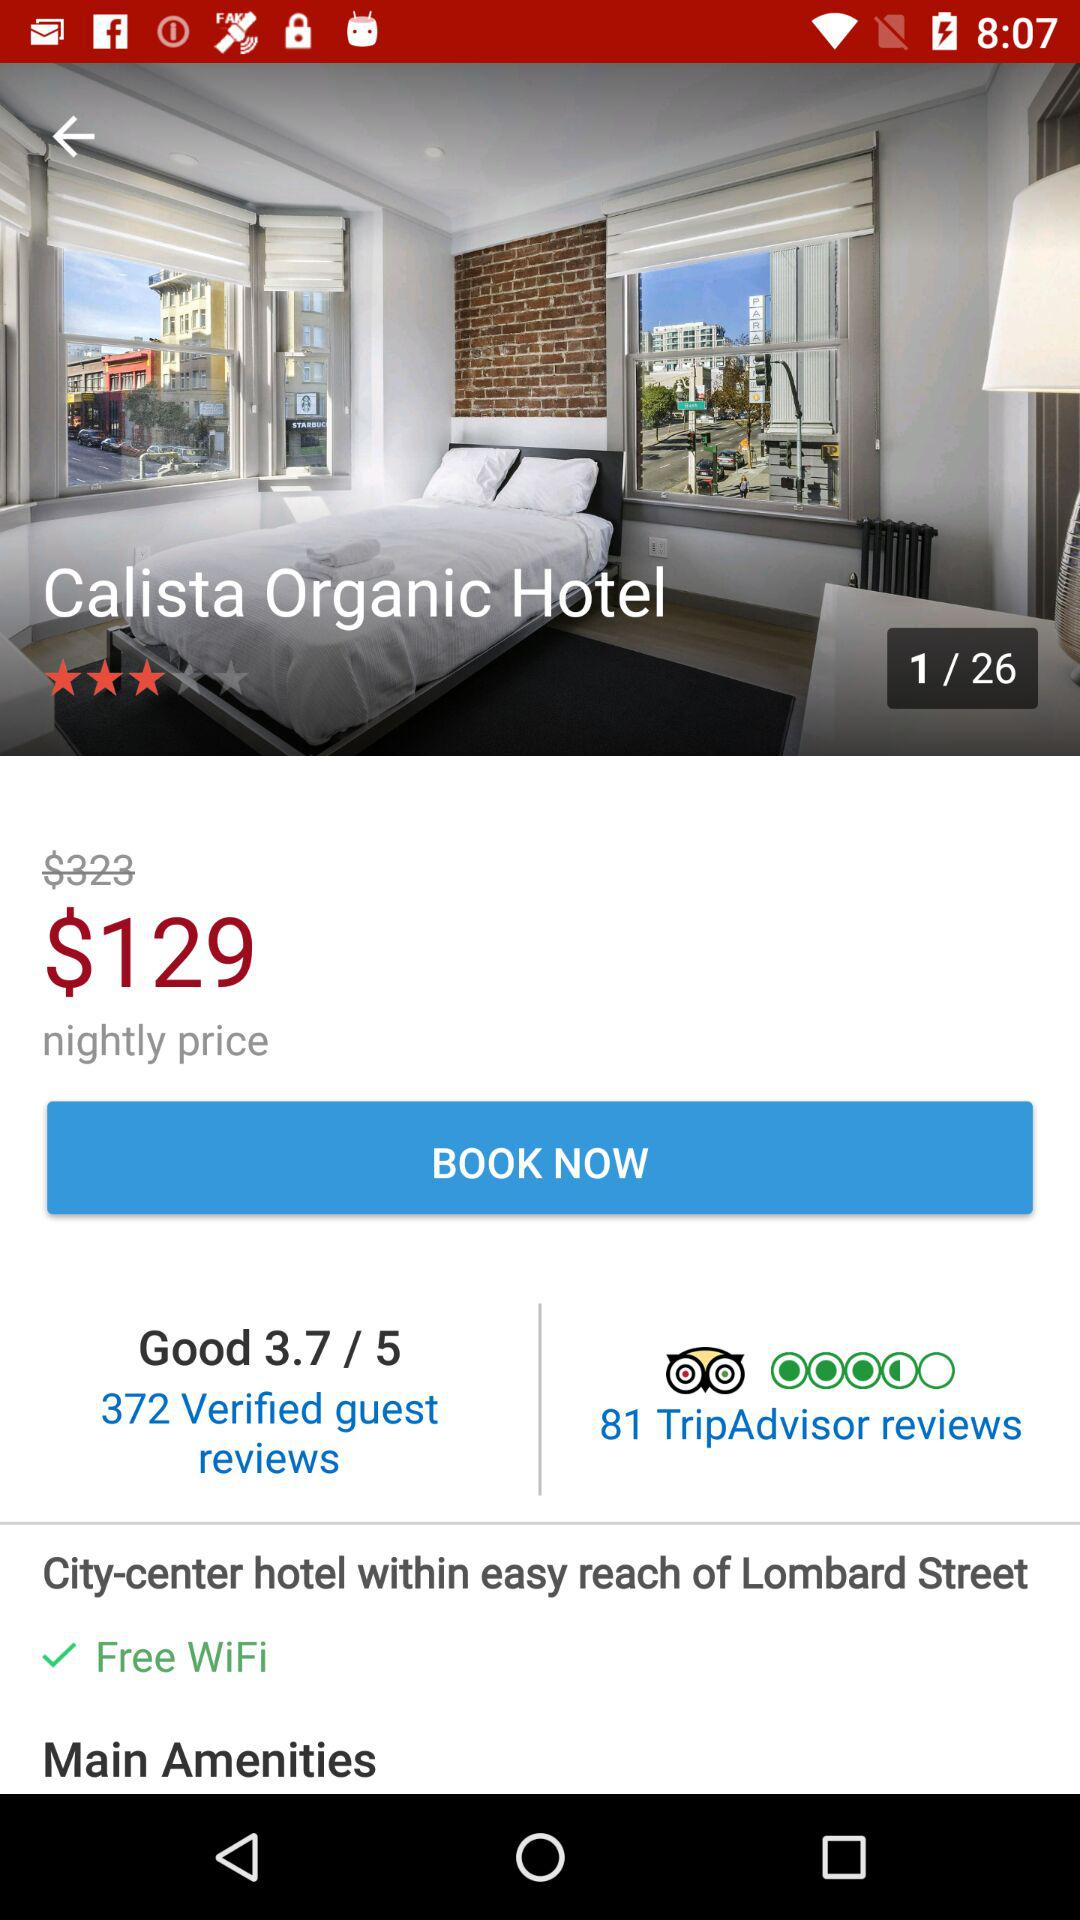What is the cost of WiFi? WiFi is free of cost. 